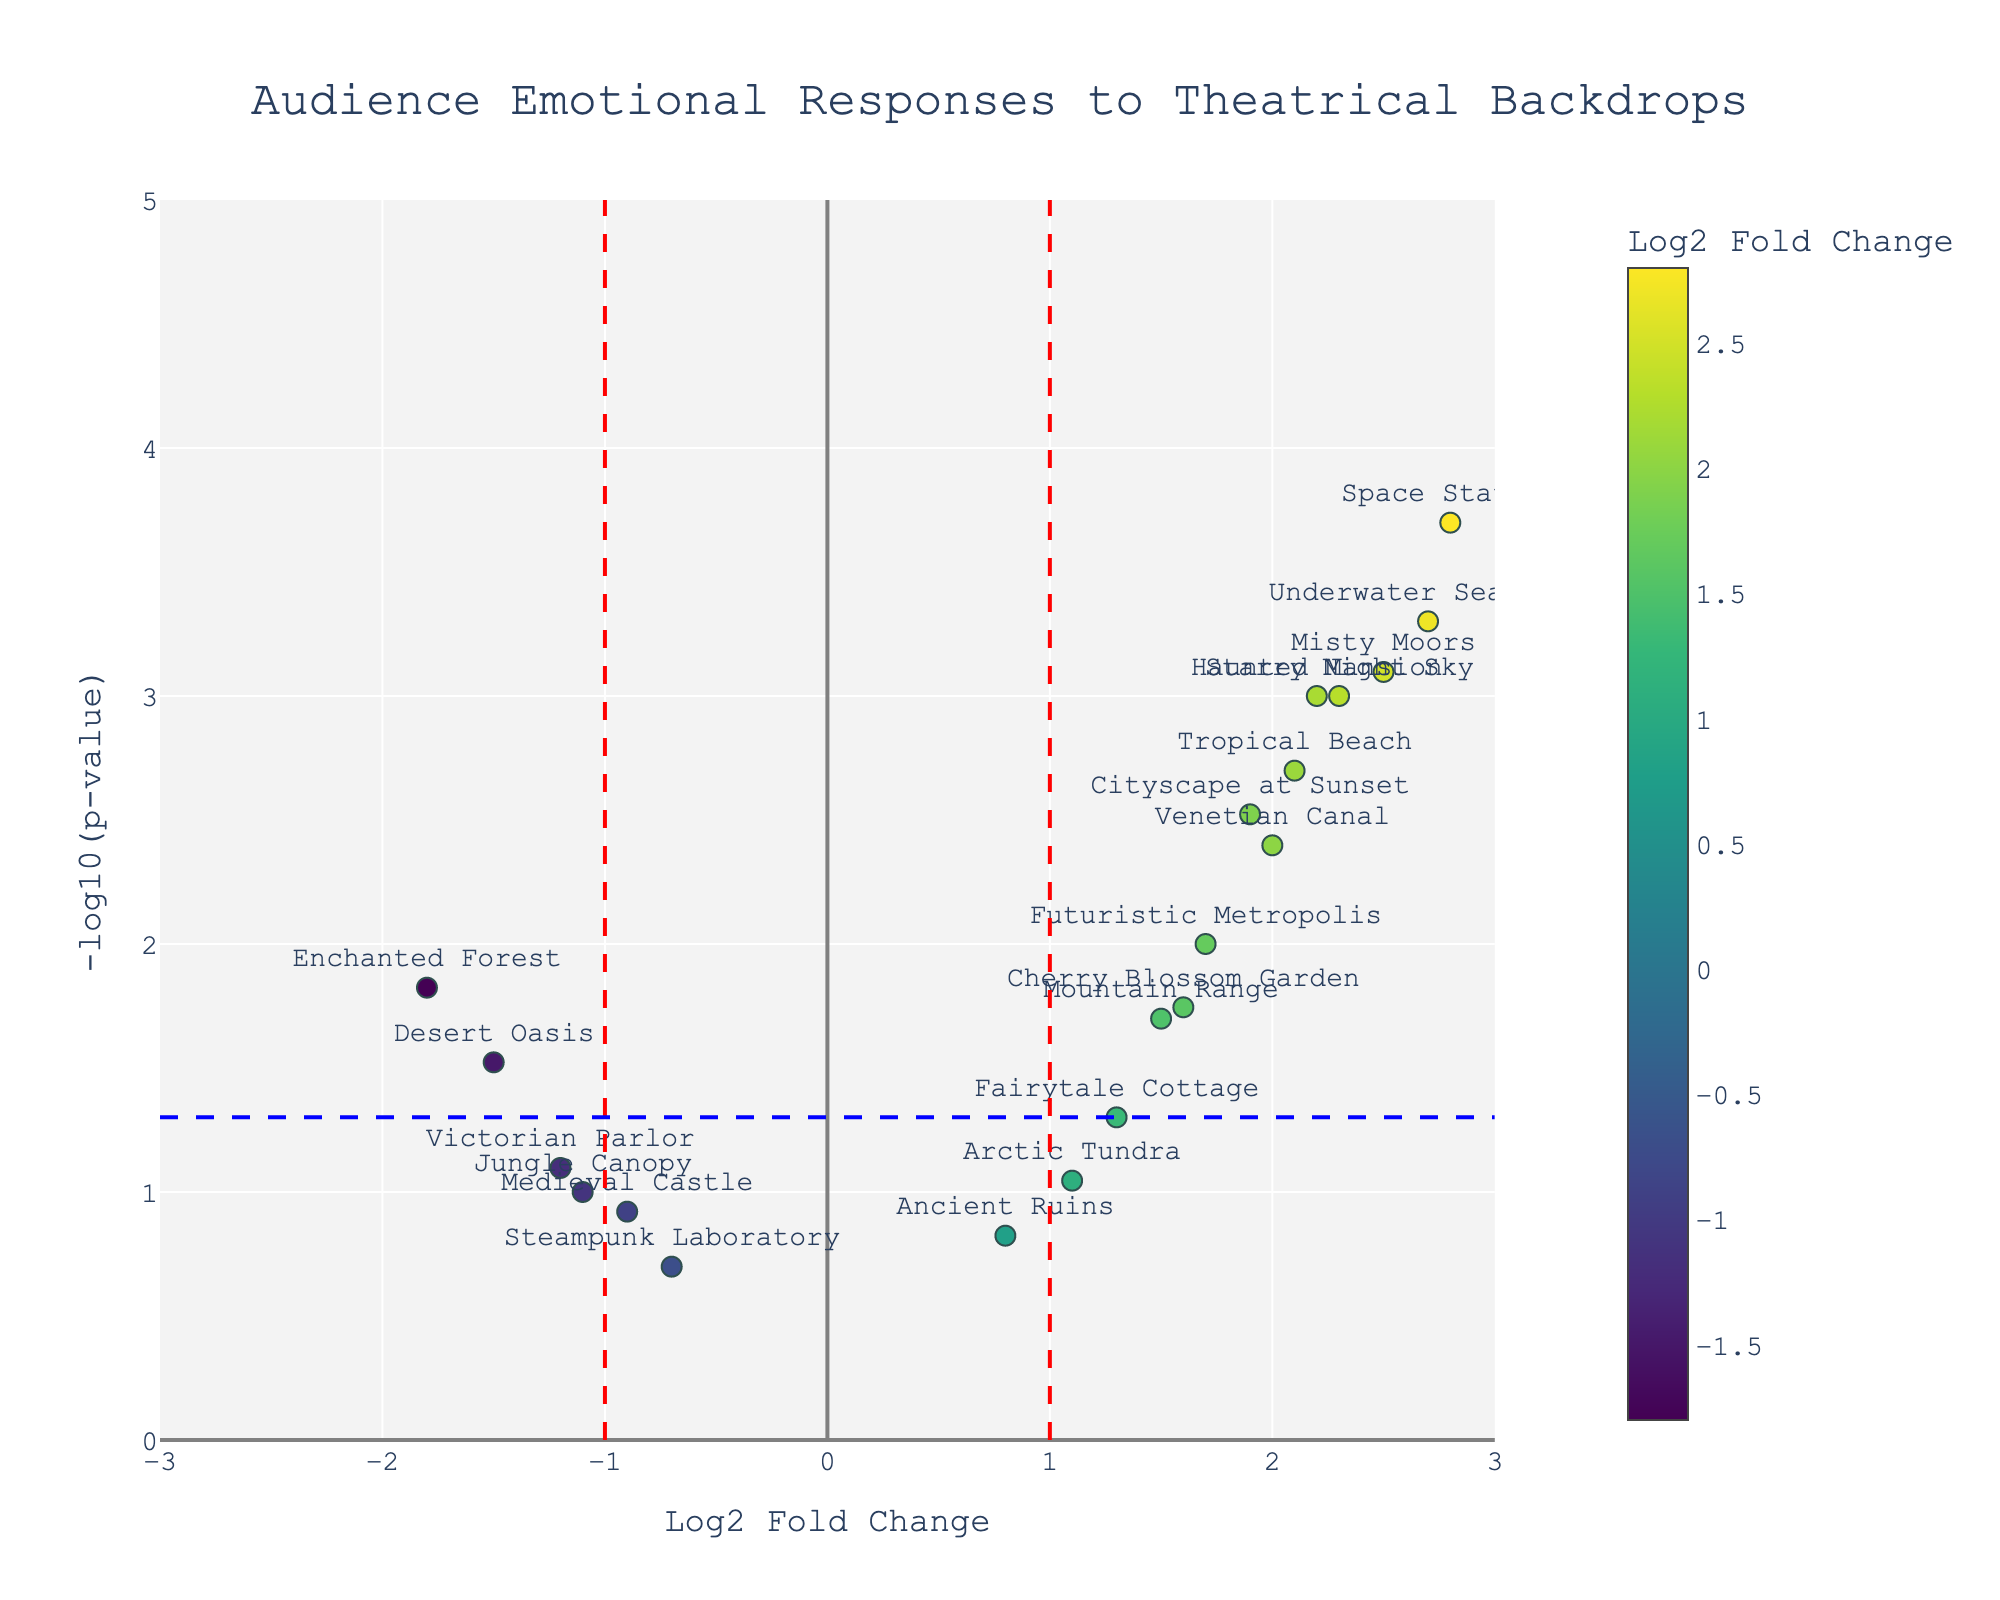What is the title of the plot? The title is usually displayed at the top of the graph to provide context. In this case, it reads "Audience Emotional Responses to Theatrical Backdrops."
Answer: Audience Emotional Responses to Theatrical Backdrops How many backdrop elements show a positive Log2 Fold Change? Count the number of data points (backdrop elements) where the Log2 Fold Change value is greater than zero.
Answer: 12 Which backdrop element has the highest -log10(p-value)? Look for the element with the highest position on the y-axis (highest -log10(p-value)). The Space Station element is the highest.
Answer: Space Station What are the criteria used for significance in this plot? Vertical lines at Log2 Fold Change of -1 and 1, and a horizontal line at -log10(p-value) of 1.3, representing a p-value threshold of 0.05. Elements outside these lines (especially above the horizontal line) are considered significant.
Answer: Vertical lines at Log2 Fold Change of -1 and 1, and horizontal line at -log10(p-value) of 1.3 Which backdrop elements are considered statistically significant and have a positive emotional response? Look for the points above the horizontal threshold and to the right of the vertical threshold (Log2 Fold Change > 1 and -log10(p-value) > 1.3). These include Starry Night Sky, Cityscape at Sunset, Underwater Seascape, Tropical Beach, Misty Moors, Space Station, Haunted Mansion, and Venetian Canal.
Answer: Starry Night Sky, Cityscape at Sunset, Underwater Seascape, Tropical Beach, Misty Moors, Space Station, Haunted Mansion, Venetian Canal How many backdrop elements have a p-value less than 0.01? Identify the points with a -log10(p-value) greater than 2, since -log10(0.01) = 2.
Answer: 7 Which backdrop has the largest positive Log2 Fold Change? Find the data point farthest to the right on the x-axis; it is Space Station with a Log2 Fold Change of 2.8.
Answer: Space Station Which backdrop elements are negatively associated (negative Log2 Fold Change) but not statistically significant? Look for data points to the left of the vertical line at Log2 Fold Change = -1 but below the horizontal line at -log10(p-value) = 1.3. These include Medieval Castle, Victorian Parlor, Steampunk Laboratory, and Jungle Canopy.
Answer: Medieval Castle, Victorian Parlor, Steampunk Laboratory, and Jungle Canopy What color scale is used to indicate Log2 Fold Change in the plot? The color scale used is 'Viridis', as indicated in the marker properties.
Answer: Viridis Which three backdrop elements have the highest positive emotional responses according to the plot? Identify the data points with the highest Log2 Fold Change values. These are Space Station (2.8), Underwater Seascape (2.7), and Misty Moors (2.5).
Answer: Space Station, Underwater Seascape, Misty Moors 